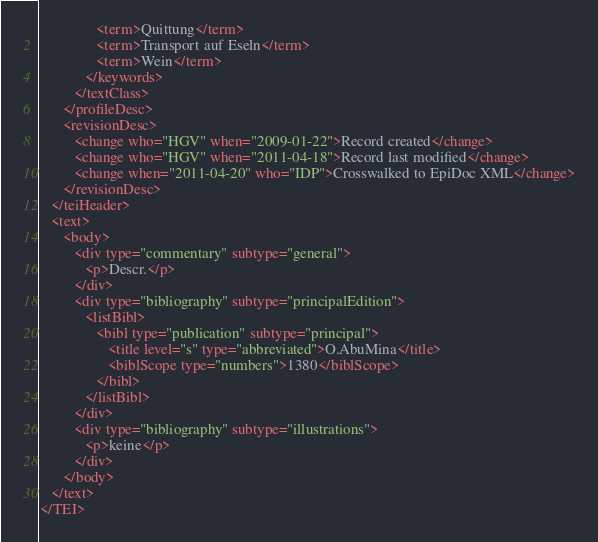Convert code to text. <code><loc_0><loc_0><loc_500><loc_500><_XML_>               <term>Quittung</term>
               <term>Transport auf Eseln</term>
               <term>Wein</term>
            </keywords>
         </textClass>
      </profileDesc>
      <revisionDesc>
         <change who="HGV" when="2009-01-22">Record created</change>
         <change who="HGV" when="2011-04-18">Record last modified</change>
         <change when="2011-04-20" who="IDP">Crosswalked to EpiDoc XML</change>
      </revisionDesc>
   </teiHeader>
   <text>
      <body>
         <div type="commentary" subtype="general">
            <p>Descr.</p>
         </div>
         <div type="bibliography" subtype="principalEdition">
            <listBibl>
               <bibl type="publication" subtype="principal">
                  <title level="s" type="abbreviated">O.AbuMina</title>
                  <biblScope type="numbers">1380</biblScope>
               </bibl>
            </listBibl>
         </div>
         <div type="bibliography" subtype="illustrations">
            <p>keine</p>
         </div>
      </body>
   </text>
</TEI>
</code> 